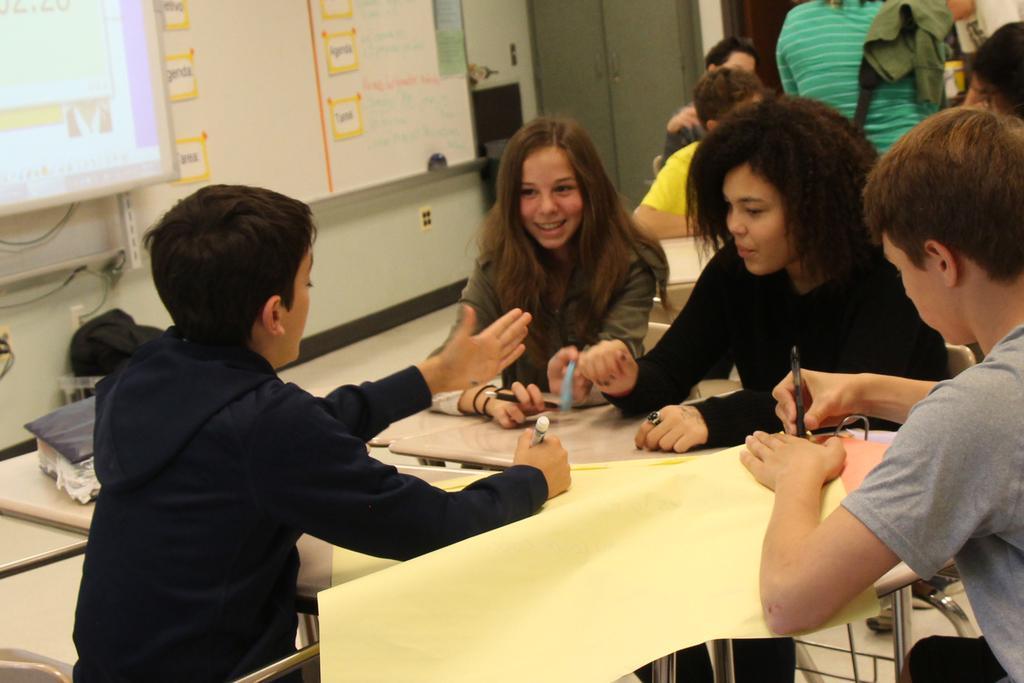Can you describe this image briefly? In this image, we can see a group of people wearing clothes and sitting in front of tables. There are two persons holding pens with their hands. There is a locker and board at the top of the image. There is a screen in the top left of the image. There is a book on the left side of the image. 